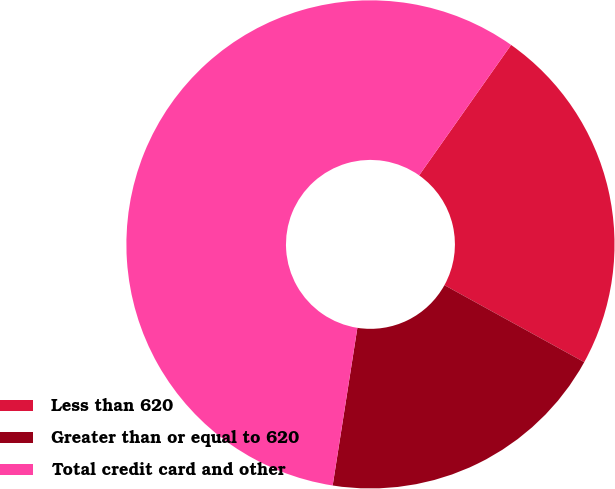Convert chart to OTSL. <chart><loc_0><loc_0><loc_500><loc_500><pie_chart><fcel>Less than 620<fcel>Greater than or equal to 620<fcel>Total credit card and other<nl><fcel>23.24%<fcel>19.46%<fcel>57.3%<nl></chart> 